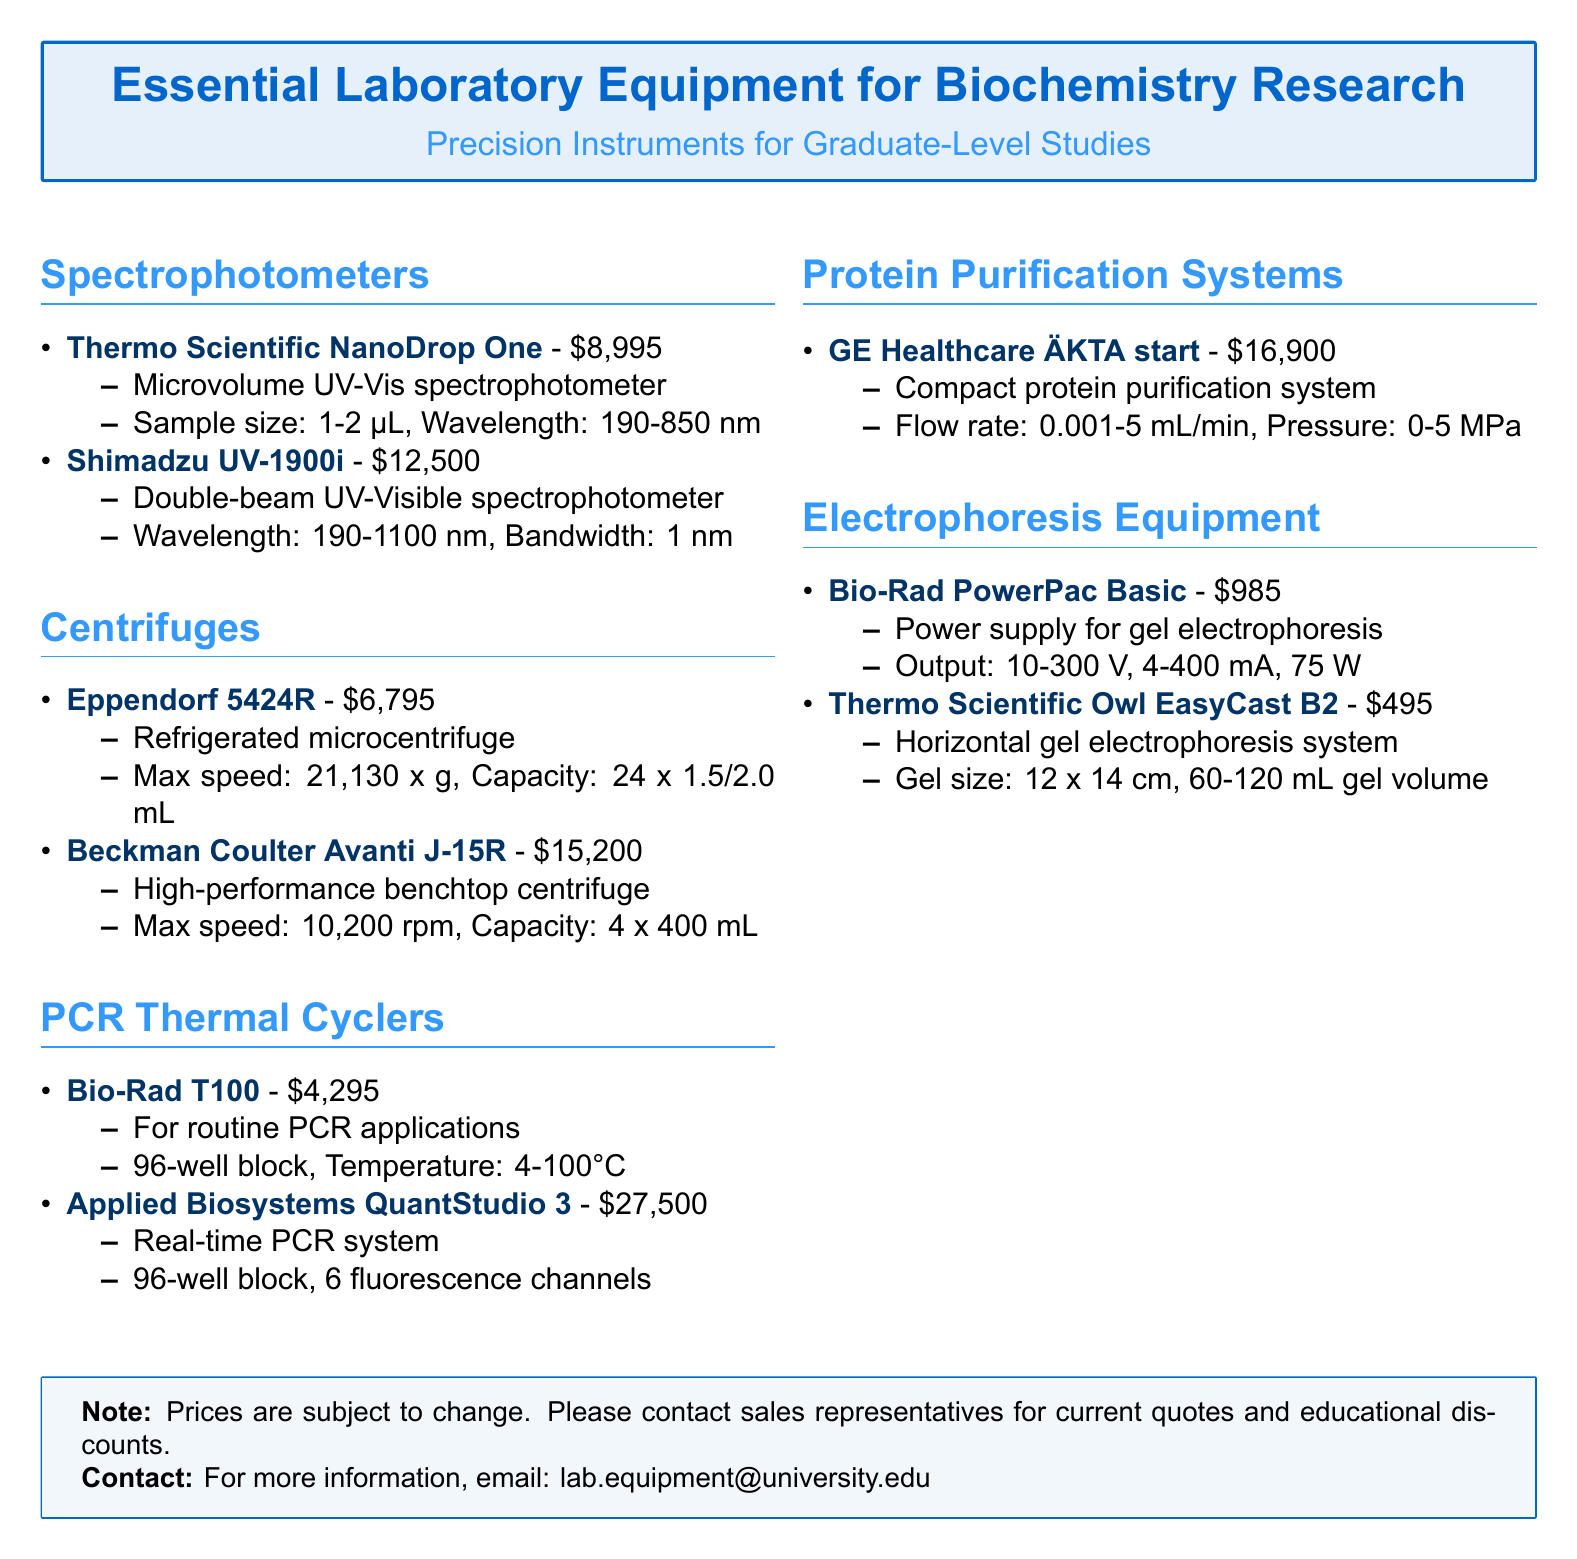What is the price of the Thermo Scientific NanoDrop One? The document lists the price of the Thermo Scientific NanoDrop One as $8,995.
Answer: $8,995 What is the maximum speed of the Eppendorf 5424R centrifuge? The document states that the maximum speed of the Eppendorf 5424R is 21,130 x g.
Answer: 21,130 x g How many fluorescence channels does the Applied Biosystems QuantStudio 3 have? The document indicates that the Applied Biosystems QuantStudio 3 has 6 fluorescence channels.
Answer: 6 What is the gel size for the Thermo Scientific Owl EasyCast B2? According to the document, the gel size for the Thermo Scientific Owl EasyCast B2 is 12 x 14 cm.
Answer: 12 x 14 cm What is the flow rate range for the GE Healthcare ÄKTA start? The document specifies that the flow rate range for the GE Healthcare ÄKTA start is 0.001-5 mL/min.
Answer: 0.001-5 mL/min Which PCR thermal cycler is listed at the highest price? The document mentions that the Applied Biosystems QuantStudio 3 is listed at the highest price of $27,500.
Answer: $27,500 What type of spectrophotometer is the Shimadzu UV-1900i? The document describes the Shimadzu UV-1900i as a double-beam UV-Visible spectrophotometer.
Answer: double-beam UV-Visible What is the output power of the Bio-Rad PowerPac Basic? The document states that the output power of the Bio-Rad PowerPac Basic is 75 W.
Answer: 75 W How many mL of maximum capacity can the Beckman Coulter Avanti J-15R hold? The document indicates that the maximum capacity of the Beckman Coulter Avanti J-15R is 4 x 400 mL.
Answer: 4 x 400 mL 